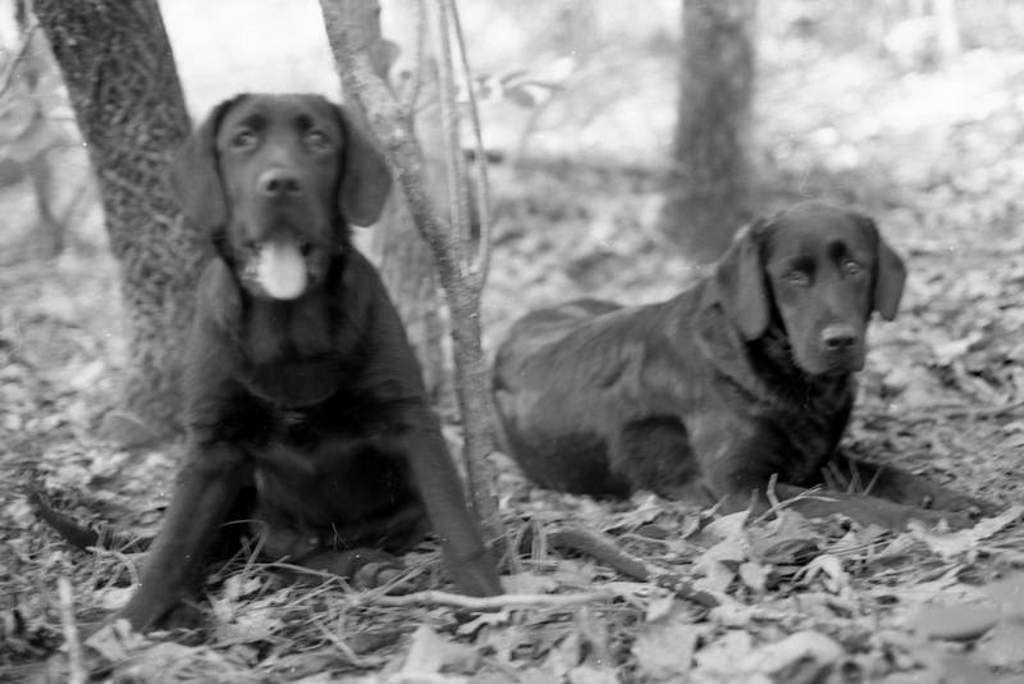What type of living organisms can be seen in the image? There are animals visible in the image. Where are the animals located in the image? The animals are on the surface. What type of feast is being held at the hospital in the image? There is no feast or hospital present in the image; it features animals on the surface. How is the hose being used by the animals in the image? There is no hose present in the image; it only features animals on the surface. 